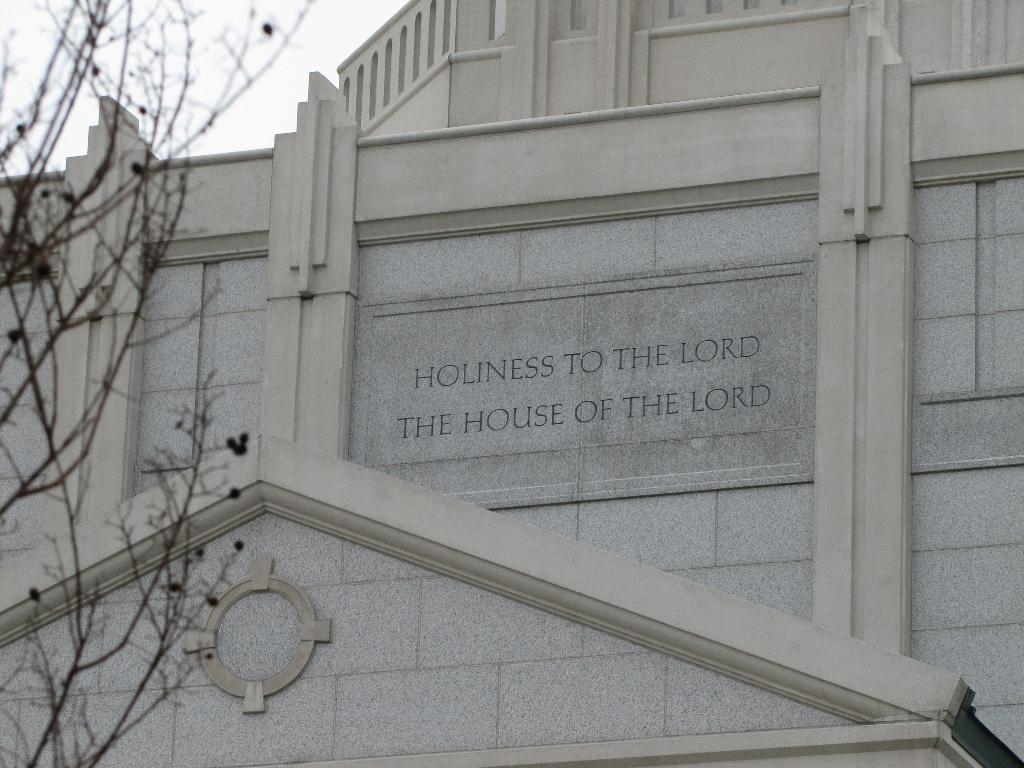What can be seen on the building wall in the image? There are letters carved on a building wall in the image. What is located on the left side of the image? There is a tree on the left side of the image. What can be seen in the background of the image? The sky is visible in the background of the image. What type of linen is draped over the tree in the image? There is no linen present in the image; it only features a tree and letters carved on a building wall. How many corn stalks are visible in the image? There is no corn present in the image. 